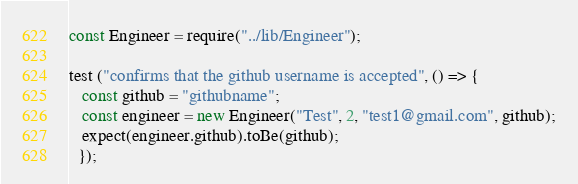<code> <loc_0><loc_0><loc_500><loc_500><_JavaScript_>const Engineer = require("../lib/Engineer");
 
test ("confirms that the github username is accepted", () => {
   const github = "githubname";
   const engineer = new Engineer("Test", 2, "test1@gmail.com", github);
   expect(engineer.github).toBe(github);
  });</code> 